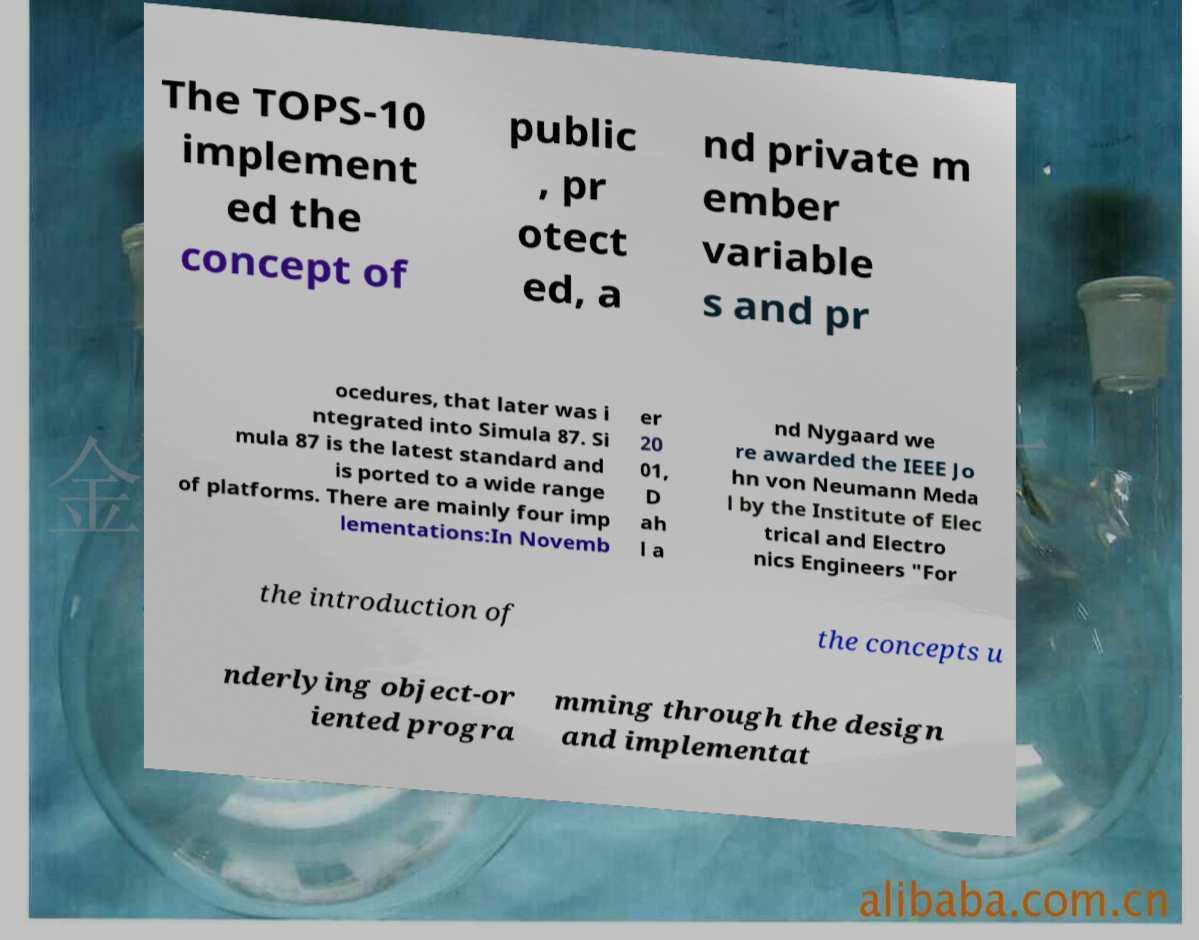Could you extract and type out the text from this image? The TOPS-10 implement ed the concept of public , pr otect ed, a nd private m ember variable s and pr ocedures, that later was i ntegrated into Simula 87. Si mula 87 is the latest standard and is ported to a wide range of platforms. There are mainly four imp lementations:In Novemb er 20 01, D ah l a nd Nygaard we re awarded the IEEE Jo hn von Neumann Meda l by the Institute of Elec trical and Electro nics Engineers "For the introduction of the concepts u nderlying object-or iented progra mming through the design and implementat 